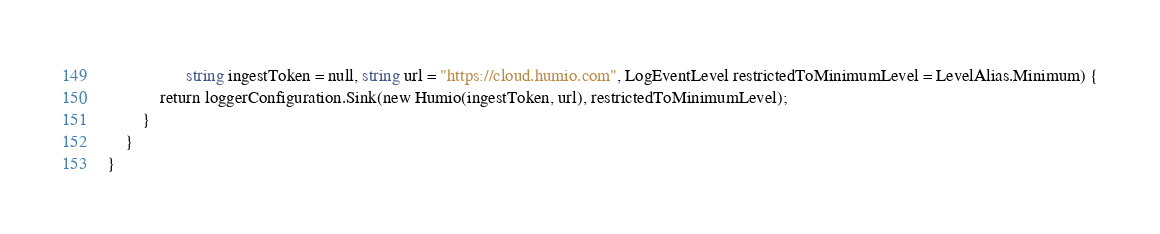Convert code to text. <code><loc_0><loc_0><loc_500><loc_500><_C#_>				  string ingestToken = null, string url = "https://cloud.humio.com", LogEventLevel restrictedToMinimumLevel = LevelAlias.Minimum) {
			return loggerConfiguration.Sink(new Humio(ingestToken, url), restrictedToMinimumLevel);
		}
	}
}</code> 